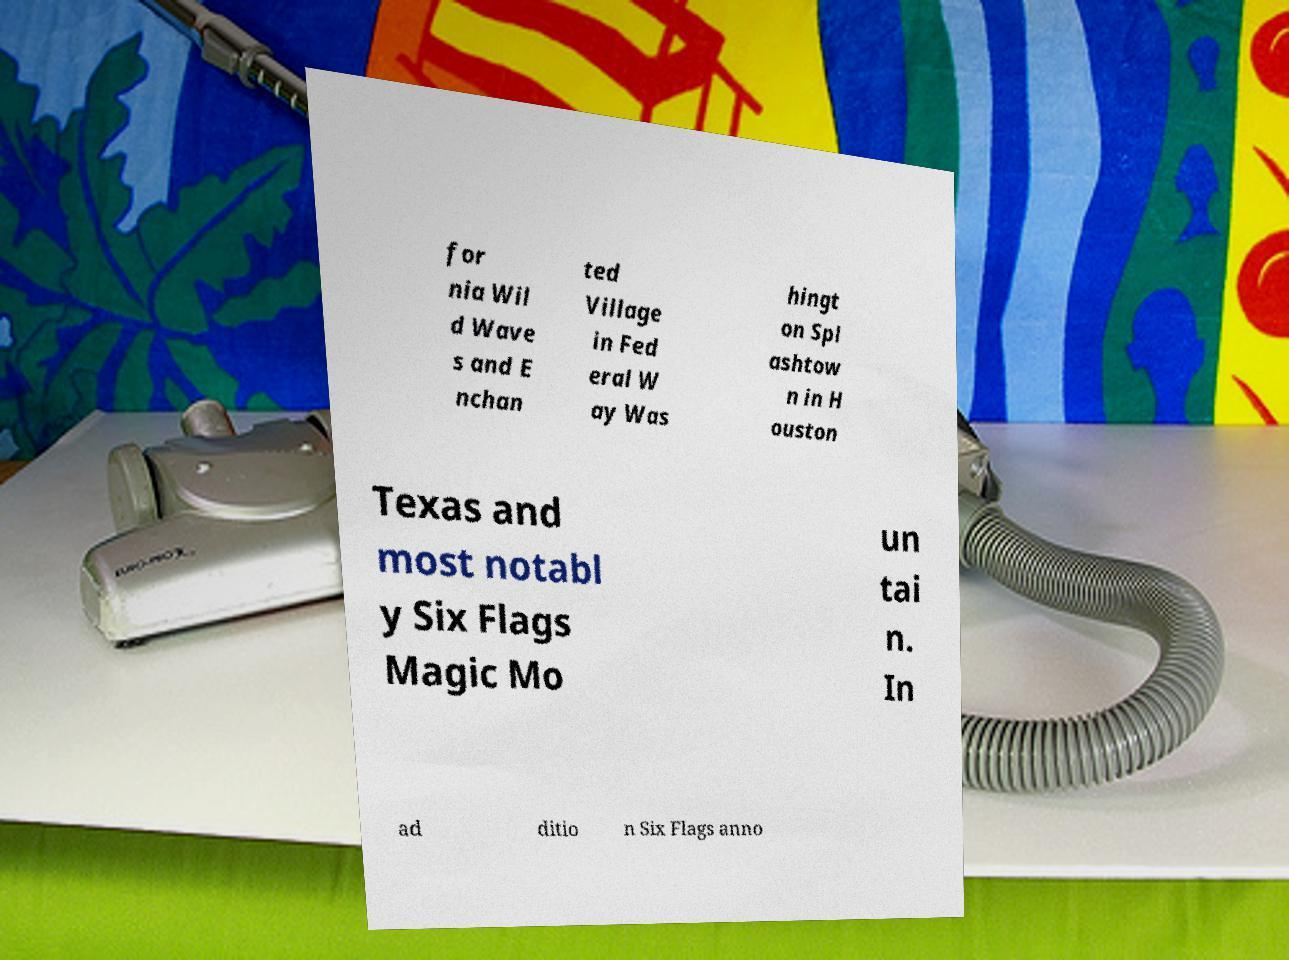I need the written content from this picture converted into text. Can you do that? for nia Wil d Wave s and E nchan ted Village in Fed eral W ay Was hingt on Spl ashtow n in H ouston Texas and most notabl y Six Flags Magic Mo un tai n. In ad ditio n Six Flags anno 